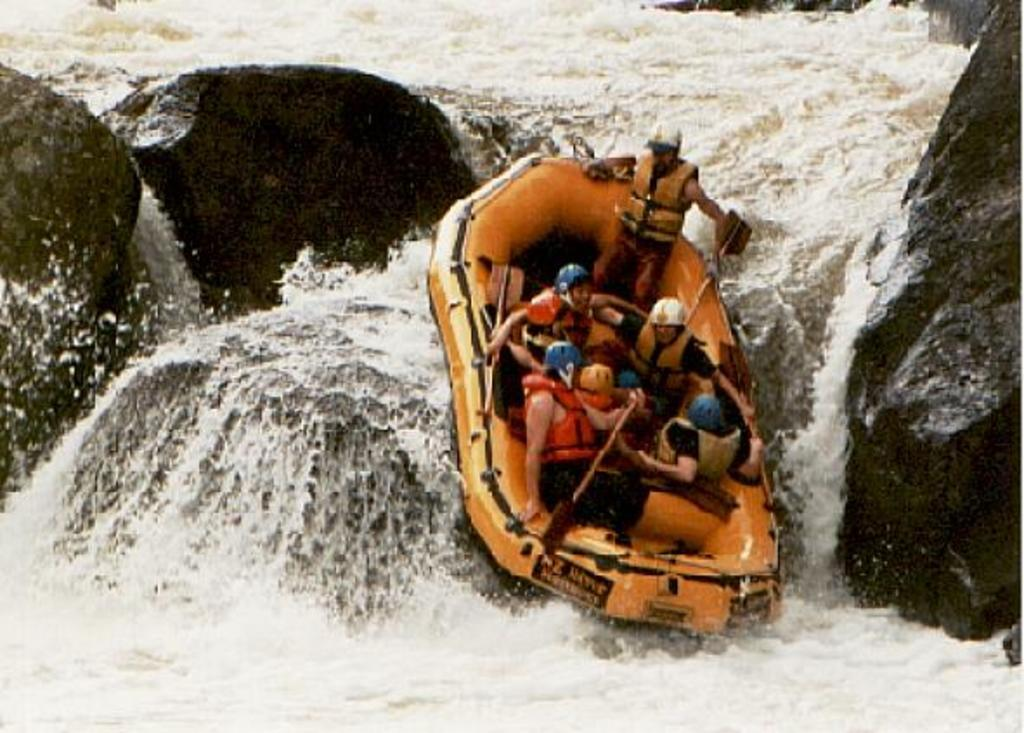What color is the boat in the image? The boat in the image is orange. Where is the boat located? The boat is on a lake. What can be seen in the lake besides the boat? There are stones visible in the lake. Who is in the boat? There are persons in the boat. What are the persons in the boat wearing? The persons in the boat are wearing helmets. What position are the persons in the boat in? The persons in the boat are sitting. Can you see any horses playing drums in the image? No, there are no horses or drums present in the image. 